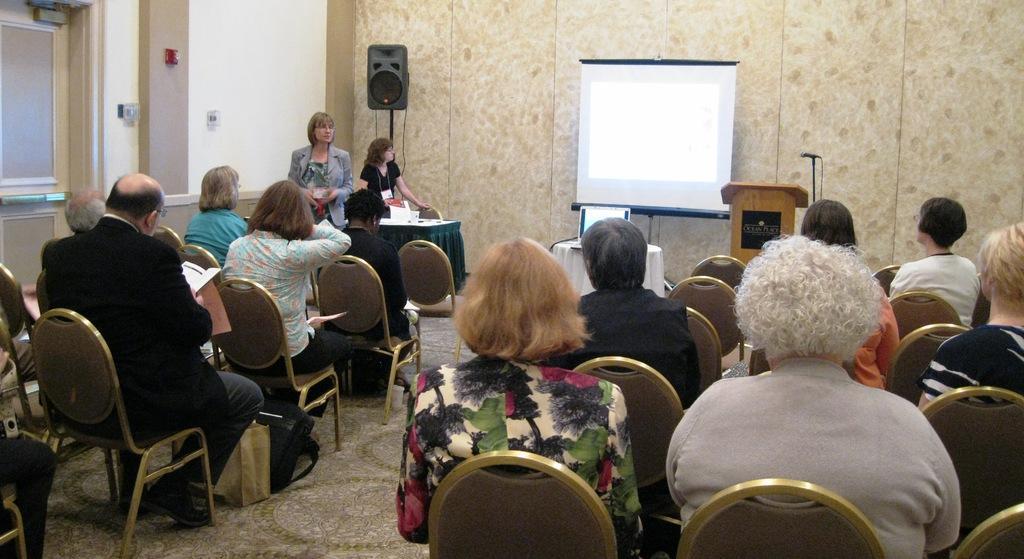Please provide a concise description of this image. In this picture we can see a group of people sitting on chairs holding papers in their hands and in front of them we have two woman standing where one is looking at the screen and in background we can see wall, laptop on table, speaker's, podium, mic. 